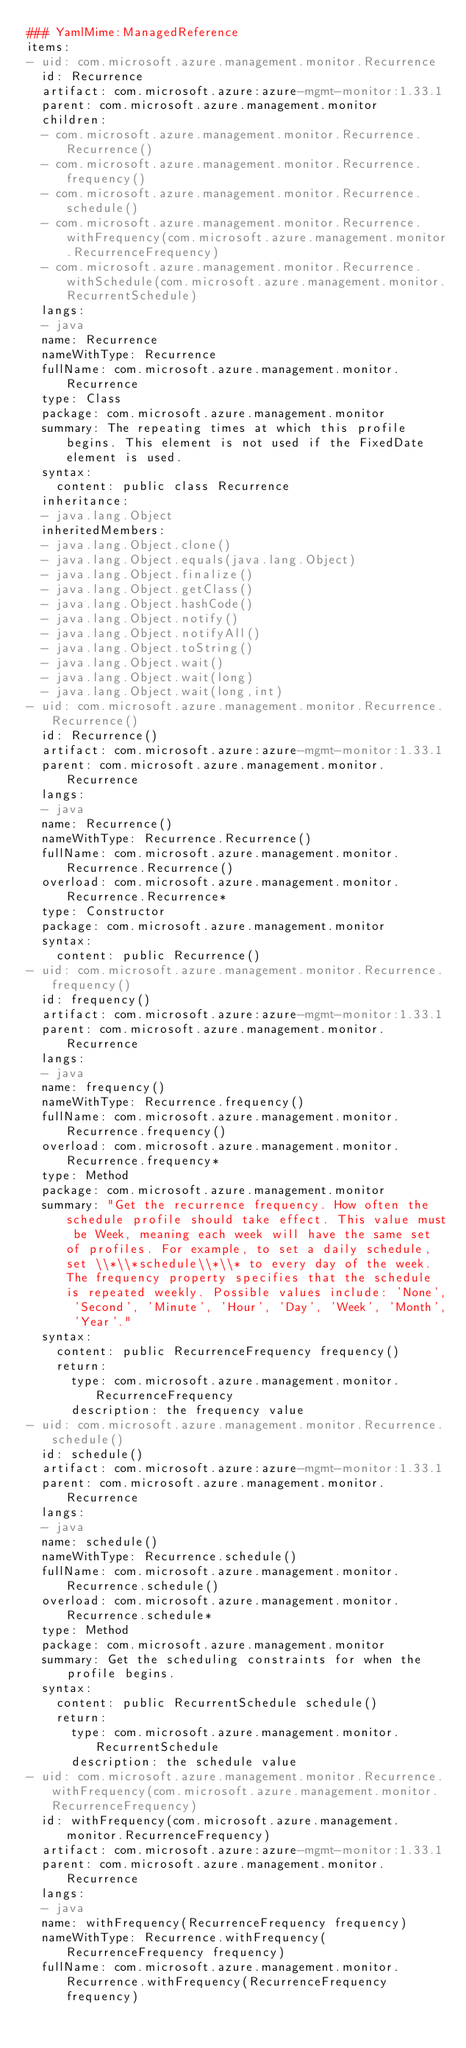Convert code to text. <code><loc_0><loc_0><loc_500><loc_500><_YAML_>### YamlMime:ManagedReference
items:
- uid: com.microsoft.azure.management.monitor.Recurrence
  id: Recurrence
  artifact: com.microsoft.azure:azure-mgmt-monitor:1.33.1
  parent: com.microsoft.azure.management.monitor
  children:
  - com.microsoft.azure.management.monitor.Recurrence.Recurrence()
  - com.microsoft.azure.management.monitor.Recurrence.frequency()
  - com.microsoft.azure.management.monitor.Recurrence.schedule()
  - com.microsoft.azure.management.monitor.Recurrence.withFrequency(com.microsoft.azure.management.monitor.RecurrenceFrequency)
  - com.microsoft.azure.management.monitor.Recurrence.withSchedule(com.microsoft.azure.management.monitor.RecurrentSchedule)
  langs:
  - java
  name: Recurrence
  nameWithType: Recurrence
  fullName: com.microsoft.azure.management.monitor.Recurrence
  type: Class
  package: com.microsoft.azure.management.monitor
  summary: The repeating times at which this profile begins. This element is not used if the FixedDate element is used.
  syntax:
    content: public class Recurrence
  inheritance:
  - java.lang.Object
  inheritedMembers:
  - java.lang.Object.clone()
  - java.lang.Object.equals(java.lang.Object)
  - java.lang.Object.finalize()
  - java.lang.Object.getClass()
  - java.lang.Object.hashCode()
  - java.lang.Object.notify()
  - java.lang.Object.notifyAll()
  - java.lang.Object.toString()
  - java.lang.Object.wait()
  - java.lang.Object.wait(long)
  - java.lang.Object.wait(long,int)
- uid: com.microsoft.azure.management.monitor.Recurrence.Recurrence()
  id: Recurrence()
  artifact: com.microsoft.azure:azure-mgmt-monitor:1.33.1
  parent: com.microsoft.azure.management.monitor.Recurrence
  langs:
  - java
  name: Recurrence()
  nameWithType: Recurrence.Recurrence()
  fullName: com.microsoft.azure.management.monitor.Recurrence.Recurrence()
  overload: com.microsoft.azure.management.monitor.Recurrence.Recurrence*
  type: Constructor
  package: com.microsoft.azure.management.monitor
  syntax:
    content: public Recurrence()
- uid: com.microsoft.azure.management.monitor.Recurrence.frequency()
  id: frequency()
  artifact: com.microsoft.azure:azure-mgmt-monitor:1.33.1
  parent: com.microsoft.azure.management.monitor.Recurrence
  langs:
  - java
  name: frequency()
  nameWithType: Recurrence.frequency()
  fullName: com.microsoft.azure.management.monitor.Recurrence.frequency()
  overload: com.microsoft.azure.management.monitor.Recurrence.frequency*
  type: Method
  package: com.microsoft.azure.management.monitor
  summary: "Get the recurrence frequency. How often the schedule profile should take effect. This value must be Week, meaning each week will have the same set of profiles. For example, to set a daily schedule, set \\*\\*schedule\\*\\* to every day of the week. The frequency property specifies that the schedule is repeated weekly. Possible values include: 'None', 'Second', 'Minute', 'Hour', 'Day', 'Week', 'Month', 'Year'."
  syntax:
    content: public RecurrenceFrequency frequency()
    return:
      type: com.microsoft.azure.management.monitor.RecurrenceFrequency
      description: the frequency value
- uid: com.microsoft.azure.management.monitor.Recurrence.schedule()
  id: schedule()
  artifact: com.microsoft.azure:azure-mgmt-monitor:1.33.1
  parent: com.microsoft.azure.management.monitor.Recurrence
  langs:
  - java
  name: schedule()
  nameWithType: Recurrence.schedule()
  fullName: com.microsoft.azure.management.monitor.Recurrence.schedule()
  overload: com.microsoft.azure.management.monitor.Recurrence.schedule*
  type: Method
  package: com.microsoft.azure.management.monitor
  summary: Get the scheduling constraints for when the profile begins.
  syntax:
    content: public RecurrentSchedule schedule()
    return:
      type: com.microsoft.azure.management.monitor.RecurrentSchedule
      description: the schedule value
- uid: com.microsoft.azure.management.monitor.Recurrence.withFrequency(com.microsoft.azure.management.monitor.RecurrenceFrequency)
  id: withFrequency(com.microsoft.azure.management.monitor.RecurrenceFrequency)
  artifact: com.microsoft.azure:azure-mgmt-monitor:1.33.1
  parent: com.microsoft.azure.management.monitor.Recurrence
  langs:
  - java
  name: withFrequency(RecurrenceFrequency frequency)
  nameWithType: Recurrence.withFrequency(RecurrenceFrequency frequency)
  fullName: com.microsoft.azure.management.monitor.Recurrence.withFrequency(RecurrenceFrequency frequency)</code> 